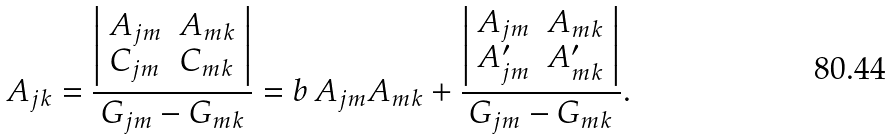Convert formula to latex. <formula><loc_0><loc_0><loc_500><loc_500>A _ { j k } = { \frac { \left | \begin{array} { l l } { { A _ { j m } } } & { { A _ { m k } } } \\ { { C _ { j m } } } & { { C _ { m k } } } \end{array} \right | } { G _ { j m } - G _ { m k } } } = b \, A _ { j m } A _ { m k } + { \frac { \left | \begin{array} { l l } { { A _ { j m } } } & { { A _ { m k } } } \\ { { A ^ { \prime } _ { j m } } } & { { A ^ { \prime } _ { m k } } } \end{array} \right | } { G _ { j m } - G _ { m k } } } .</formula> 